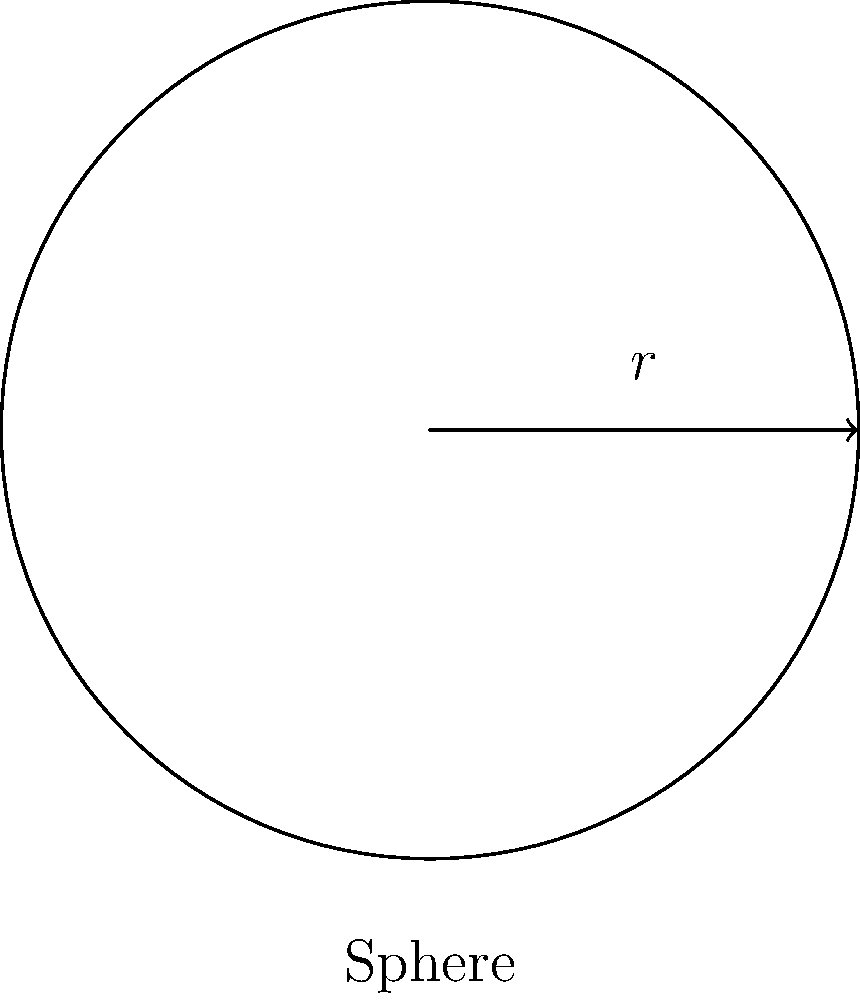You're tasked with creating a function to calculate the surface area of a sphere. Given a sphere with radius $r = 5$ units, what is its surface area? Use the formula $A = 4\pi r^2$, where $A$ is the surface area and $r$ is the radius. Round your answer to two decimal places. To solve this problem, let's break it down into steps:

1. Identify the given information:
   - Radius $r = 5$ units
   - Formula: $A = 4\pi r^2$

2. Substitute the radius into the formula:
   $A = 4\pi (5)^2$

3. Calculate the square of the radius:
   $A = 4\pi (25)$

4. Multiply by 4π:
   $A = 100\pi$

5. Calculate the value of π (approximately 3.14159):
   $A \approx 100 * 3.14159 = 314.159$

6. Round the result to two decimal places:
   $A \approx 314.16$ square units

Therefore, the surface area of the sphere with radius 5 units is approximately 314.16 square units.
Answer: 314.16 square units 